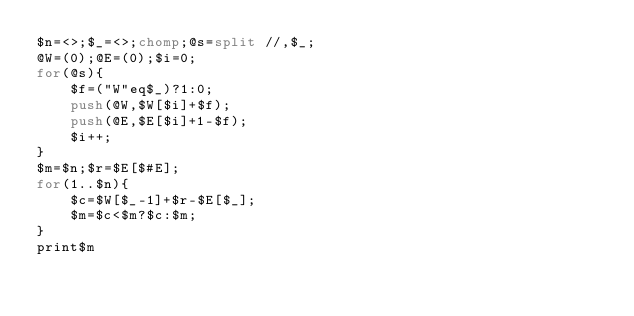Convert code to text. <code><loc_0><loc_0><loc_500><loc_500><_Perl_>$n=<>;$_=<>;chomp;@s=split //,$_;
@W=(0);@E=(0);$i=0;
for(@s){
    $f=("W"eq$_)?1:0;
    push(@W,$W[$i]+$f);
    push(@E,$E[$i]+1-$f);
    $i++;
}
$m=$n;$r=$E[$#E];
for(1..$n){
    $c=$W[$_-1]+$r-$E[$_];
    $m=$c<$m?$c:$m;
}
print$m</code> 